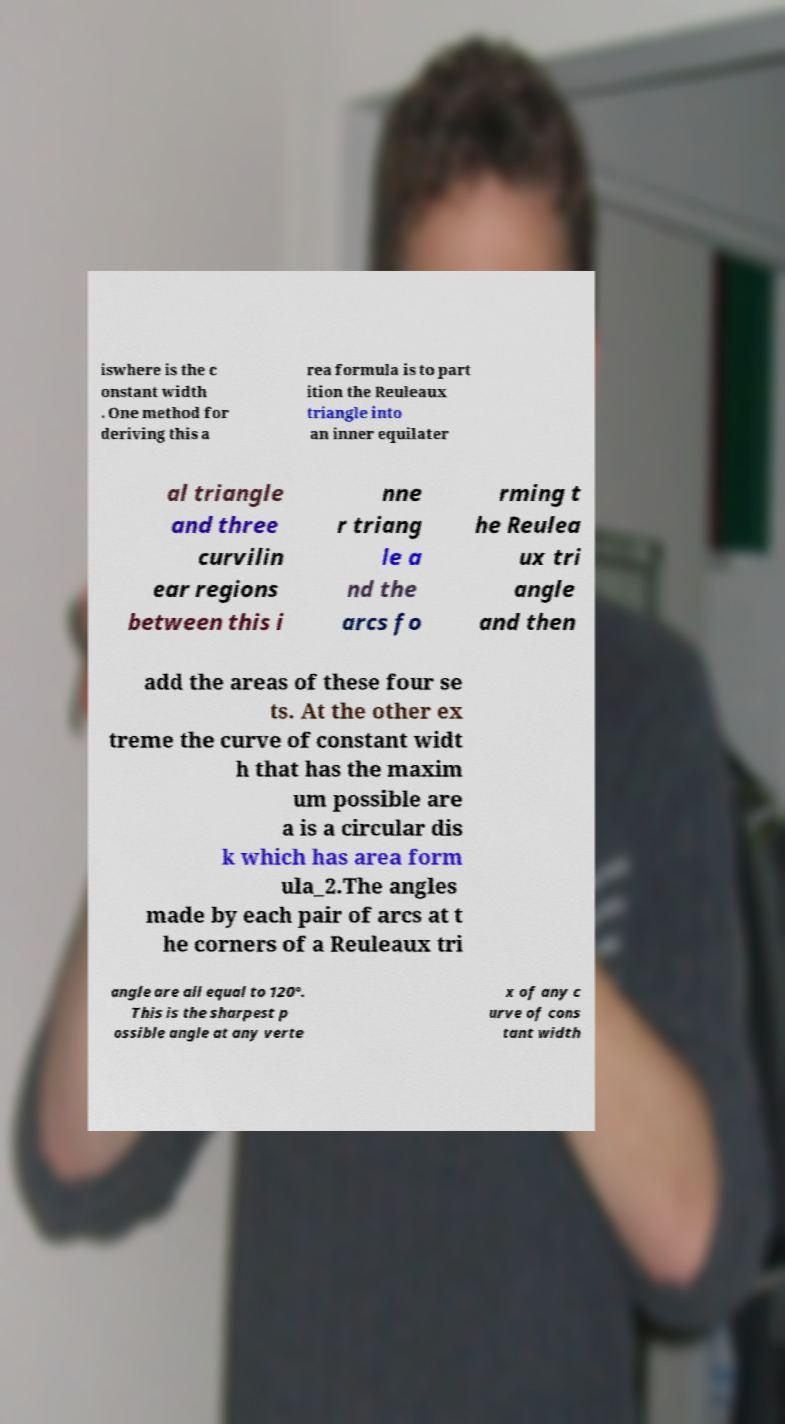What messages or text are displayed in this image? I need them in a readable, typed format. iswhere is the c onstant width . One method for deriving this a rea formula is to part ition the Reuleaux triangle into an inner equilater al triangle and three curvilin ear regions between this i nne r triang le a nd the arcs fo rming t he Reulea ux tri angle and then add the areas of these four se ts. At the other ex treme the curve of constant widt h that has the maxim um possible are a is a circular dis k which has area form ula_2.The angles made by each pair of arcs at t he corners of a Reuleaux tri angle are all equal to 120°. This is the sharpest p ossible angle at any verte x of any c urve of cons tant width 